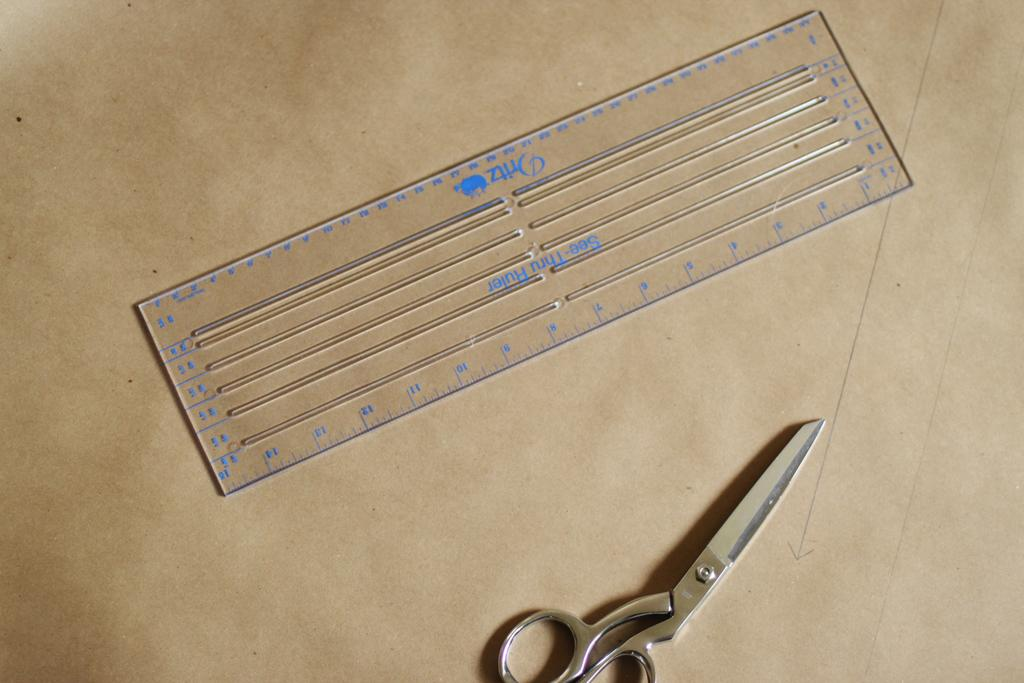What is present on the paper in the image? The paper has a cream and brown color, a scale, scissors, and lines drawn on it. Can you describe the color of the paper? The paper has a cream and brown color. What objects are on the paper? There is a scale and scissors on the paper. Are there any markings or drawings on the paper? Yes, there are lines drawn on the paper. What is the value of the gold coin depicted on the paper? There is no gold coin present on the paper; it only has a scale, scissors, and lines drawn on it. 